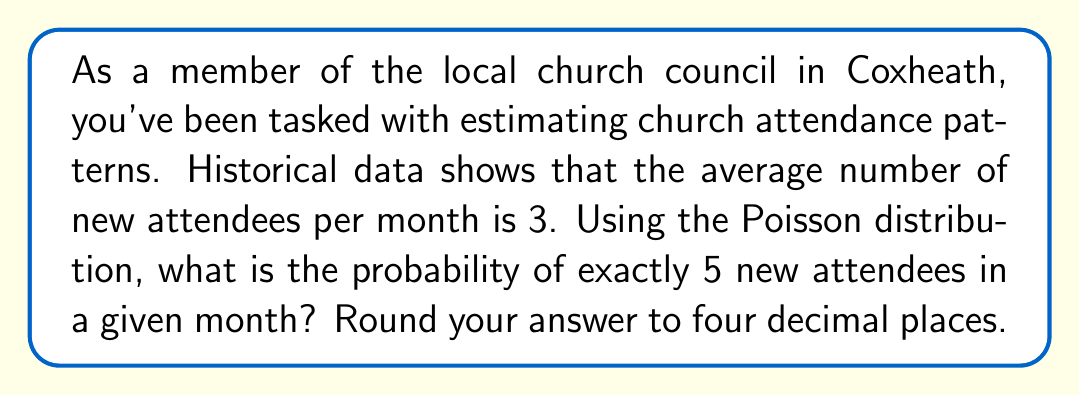Solve this math problem. To solve this problem, we'll use the Poisson distribution formula:

$$P(X = k) = \frac{e^{-\lambda} \lambda^k}{k!}$$

Where:
$\lambda$ = average number of events in the interval
$k$ = number of events we're calculating the probability for
$e$ = Euler's number (approximately 2.71828)

Given:
$\lambda = 3$ (average number of new attendees per month)
$k = 5$ (we're calculating the probability of exactly 5 new attendees)

Step 1: Plug the values into the formula:
$$P(X = 5) = \frac{e^{-3} 3^5}{5!}$$

Step 2: Calculate $e^{-3}$:
$$e^{-3} \approx 0.0497871$$

Step 3: Calculate $3^5$:
$$3^5 = 243$$

Step 4: Calculate $5!$:
$$5! = 5 \times 4 \times 3 \times 2 \times 1 = 120$$

Step 5: Put it all together:
$$P(X = 5) = \frac{0.0497871 \times 243}{120}$$

Step 6: Perform the calculation:
$$P(X = 5) \approx 0.1008$$

Step 7: Round to four decimal places:
$$P(X = 5) \approx 0.1008$$
Answer: 0.1008 